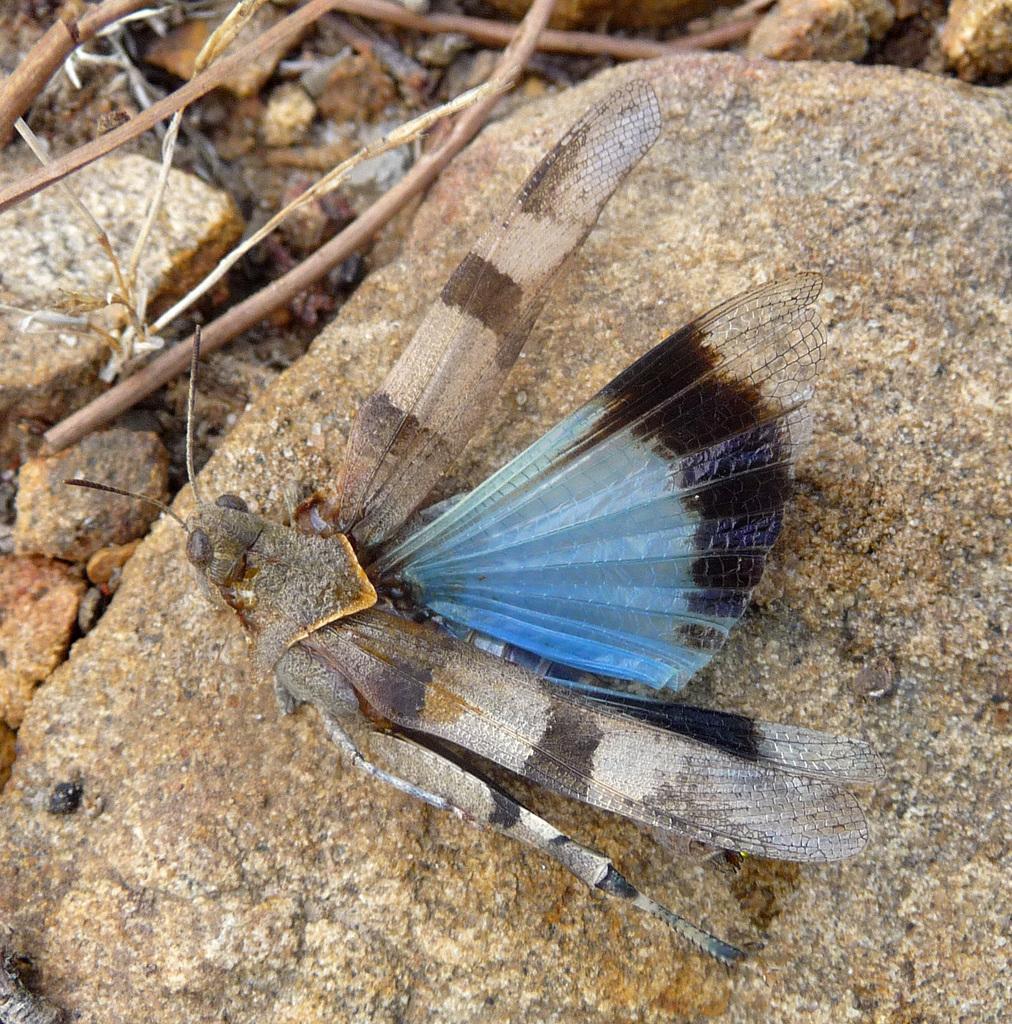Could you give a brief overview of what you see in this image? In the center of the image, we can see a fly and in the background, there are rocks and we can see twigs. 